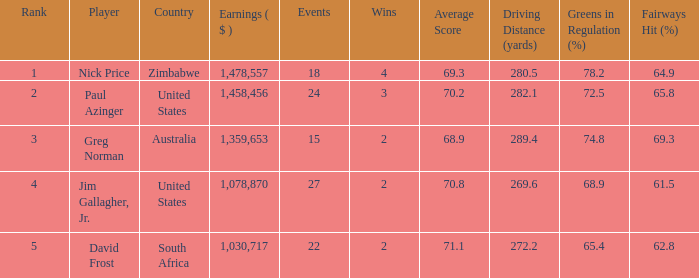How many events have earnings less than 1,030,717? 0.0. 